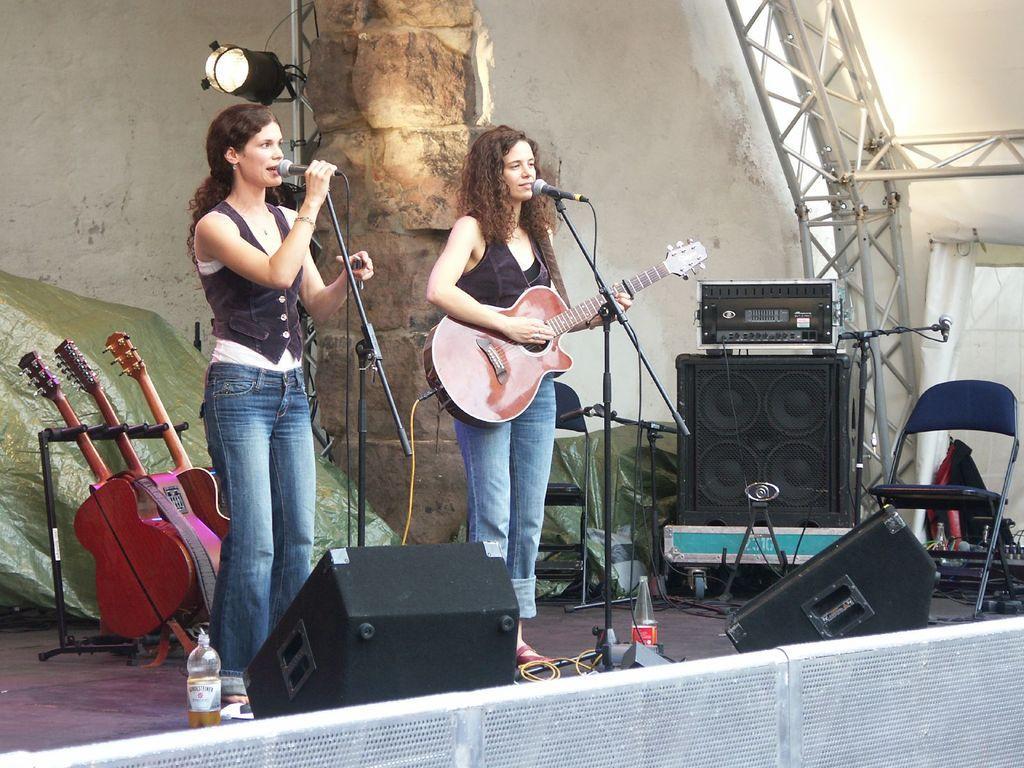In one or two sentences, can you explain what this image depicts? In this image one lady is singing beside her another lady is playing guitar. In front of them there are mics. On the stage there are bottles, speakers, few guitars on stand, chair, lights are there. 